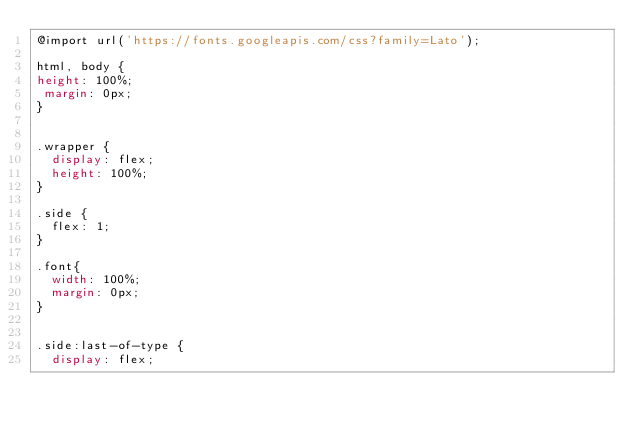<code> <loc_0><loc_0><loc_500><loc_500><_CSS_>@import url('https://fonts.googleapis.com/css?family=Lato');

html, body {
height: 100%;
 margin: 0px; 
}


.wrapper {
  display: flex;
  height: 100%;
}

.side {
  flex: 1;
}

.font{
  width: 100%;
  margin: 0px;
}


.side:last-of-type {
  display: flex;</code> 